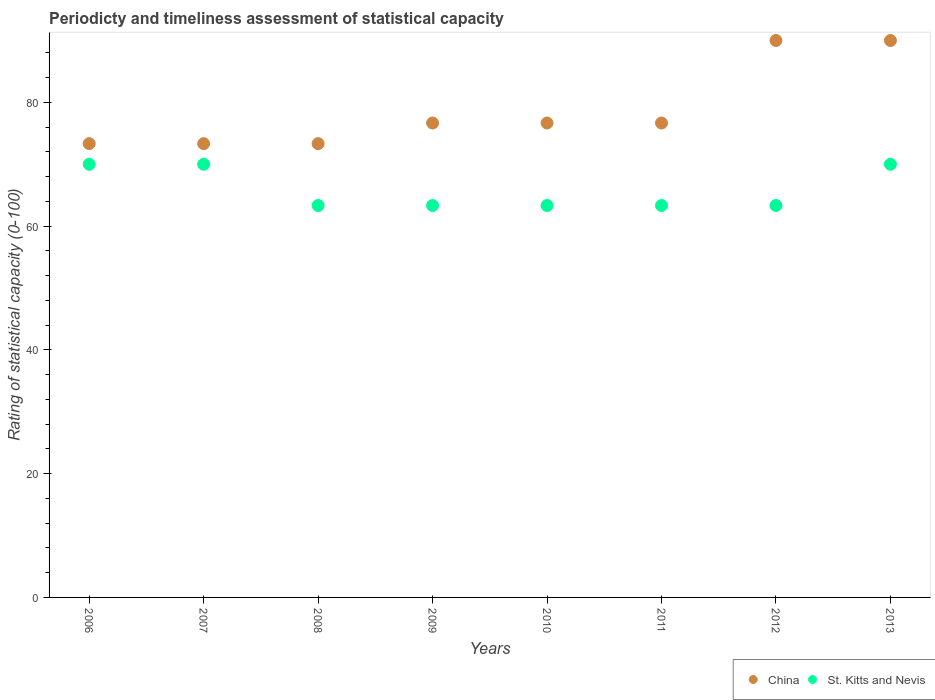How many different coloured dotlines are there?
Offer a very short reply. 2. Is the number of dotlines equal to the number of legend labels?
Your response must be concise. Yes. What is the rating of statistical capacity in China in 2011?
Your answer should be very brief. 76.67. Across all years, what is the minimum rating of statistical capacity in China?
Your answer should be compact. 73.33. In which year was the rating of statistical capacity in China maximum?
Your answer should be compact. 2012. What is the total rating of statistical capacity in China in the graph?
Your response must be concise. 630. What is the difference between the rating of statistical capacity in China in 2008 and that in 2013?
Your answer should be compact. -16.67. What is the difference between the rating of statistical capacity in China in 2013 and the rating of statistical capacity in St. Kitts and Nevis in 2009?
Offer a terse response. 26.67. What is the average rating of statistical capacity in St. Kitts and Nevis per year?
Give a very brief answer. 65.83. In the year 2006, what is the difference between the rating of statistical capacity in St. Kitts and Nevis and rating of statistical capacity in China?
Ensure brevity in your answer.  -3.33. In how many years, is the rating of statistical capacity in St. Kitts and Nevis greater than 4?
Your answer should be compact. 8. What is the ratio of the rating of statistical capacity in St. Kitts and Nevis in 2006 to that in 2008?
Your answer should be very brief. 1.11. Is the rating of statistical capacity in China in 2006 less than that in 2009?
Your answer should be compact. Yes. What is the difference between the highest and the lowest rating of statistical capacity in China?
Keep it short and to the point. 16.67. Is the sum of the rating of statistical capacity in St. Kitts and Nevis in 2008 and 2009 greater than the maximum rating of statistical capacity in China across all years?
Provide a succinct answer. Yes. Does the rating of statistical capacity in China monotonically increase over the years?
Your answer should be compact. No. Is the rating of statistical capacity in China strictly less than the rating of statistical capacity in St. Kitts and Nevis over the years?
Your answer should be compact. No. How many dotlines are there?
Give a very brief answer. 2. How many years are there in the graph?
Provide a short and direct response. 8. Are the values on the major ticks of Y-axis written in scientific E-notation?
Provide a short and direct response. No. How many legend labels are there?
Provide a succinct answer. 2. How are the legend labels stacked?
Provide a succinct answer. Horizontal. What is the title of the graph?
Offer a very short reply. Periodicty and timeliness assessment of statistical capacity. Does "Malawi" appear as one of the legend labels in the graph?
Offer a very short reply. No. What is the label or title of the X-axis?
Offer a very short reply. Years. What is the label or title of the Y-axis?
Offer a very short reply. Rating of statistical capacity (0-100). What is the Rating of statistical capacity (0-100) in China in 2006?
Your answer should be compact. 73.33. What is the Rating of statistical capacity (0-100) of St. Kitts and Nevis in 2006?
Ensure brevity in your answer.  70. What is the Rating of statistical capacity (0-100) of China in 2007?
Your answer should be very brief. 73.33. What is the Rating of statistical capacity (0-100) of St. Kitts and Nevis in 2007?
Your answer should be compact. 70. What is the Rating of statistical capacity (0-100) of China in 2008?
Offer a very short reply. 73.33. What is the Rating of statistical capacity (0-100) in St. Kitts and Nevis in 2008?
Offer a very short reply. 63.33. What is the Rating of statistical capacity (0-100) of China in 2009?
Ensure brevity in your answer.  76.67. What is the Rating of statistical capacity (0-100) of St. Kitts and Nevis in 2009?
Offer a terse response. 63.33. What is the Rating of statistical capacity (0-100) in China in 2010?
Offer a very short reply. 76.67. What is the Rating of statistical capacity (0-100) in St. Kitts and Nevis in 2010?
Provide a succinct answer. 63.33. What is the Rating of statistical capacity (0-100) in China in 2011?
Offer a terse response. 76.67. What is the Rating of statistical capacity (0-100) of St. Kitts and Nevis in 2011?
Ensure brevity in your answer.  63.33. What is the Rating of statistical capacity (0-100) in St. Kitts and Nevis in 2012?
Give a very brief answer. 63.33. Across all years, what is the maximum Rating of statistical capacity (0-100) of St. Kitts and Nevis?
Your answer should be very brief. 70. Across all years, what is the minimum Rating of statistical capacity (0-100) in China?
Provide a succinct answer. 73.33. Across all years, what is the minimum Rating of statistical capacity (0-100) of St. Kitts and Nevis?
Offer a very short reply. 63.33. What is the total Rating of statistical capacity (0-100) in China in the graph?
Your answer should be compact. 630. What is the total Rating of statistical capacity (0-100) in St. Kitts and Nevis in the graph?
Your answer should be compact. 526.67. What is the difference between the Rating of statistical capacity (0-100) in China in 2006 and that in 2007?
Make the answer very short. 0. What is the difference between the Rating of statistical capacity (0-100) of St. Kitts and Nevis in 2006 and that in 2008?
Your answer should be compact. 6.67. What is the difference between the Rating of statistical capacity (0-100) of China in 2006 and that in 2009?
Make the answer very short. -3.33. What is the difference between the Rating of statistical capacity (0-100) in St. Kitts and Nevis in 2006 and that in 2009?
Your answer should be compact. 6.67. What is the difference between the Rating of statistical capacity (0-100) of St. Kitts and Nevis in 2006 and that in 2010?
Give a very brief answer. 6.67. What is the difference between the Rating of statistical capacity (0-100) in St. Kitts and Nevis in 2006 and that in 2011?
Provide a succinct answer. 6.67. What is the difference between the Rating of statistical capacity (0-100) in China in 2006 and that in 2012?
Offer a terse response. -16.67. What is the difference between the Rating of statistical capacity (0-100) of St. Kitts and Nevis in 2006 and that in 2012?
Your answer should be very brief. 6.67. What is the difference between the Rating of statistical capacity (0-100) in China in 2006 and that in 2013?
Ensure brevity in your answer.  -16.67. What is the difference between the Rating of statistical capacity (0-100) in St. Kitts and Nevis in 2006 and that in 2013?
Your response must be concise. 0. What is the difference between the Rating of statistical capacity (0-100) of China in 2007 and that in 2012?
Provide a short and direct response. -16.67. What is the difference between the Rating of statistical capacity (0-100) of St. Kitts and Nevis in 2007 and that in 2012?
Give a very brief answer. 6.67. What is the difference between the Rating of statistical capacity (0-100) of China in 2007 and that in 2013?
Your response must be concise. -16.67. What is the difference between the Rating of statistical capacity (0-100) in China in 2008 and that in 2009?
Provide a succinct answer. -3.33. What is the difference between the Rating of statistical capacity (0-100) in St. Kitts and Nevis in 2008 and that in 2009?
Ensure brevity in your answer.  0. What is the difference between the Rating of statistical capacity (0-100) in St. Kitts and Nevis in 2008 and that in 2010?
Make the answer very short. 0. What is the difference between the Rating of statistical capacity (0-100) in St. Kitts and Nevis in 2008 and that in 2011?
Ensure brevity in your answer.  0. What is the difference between the Rating of statistical capacity (0-100) in China in 2008 and that in 2012?
Make the answer very short. -16.67. What is the difference between the Rating of statistical capacity (0-100) of St. Kitts and Nevis in 2008 and that in 2012?
Provide a short and direct response. 0. What is the difference between the Rating of statistical capacity (0-100) of China in 2008 and that in 2013?
Your answer should be very brief. -16.67. What is the difference between the Rating of statistical capacity (0-100) in St. Kitts and Nevis in 2008 and that in 2013?
Your response must be concise. -6.67. What is the difference between the Rating of statistical capacity (0-100) in China in 2009 and that in 2012?
Provide a succinct answer. -13.33. What is the difference between the Rating of statistical capacity (0-100) in St. Kitts and Nevis in 2009 and that in 2012?
Offer a very short reply. 0. What is the difference between the Rating of statistical capacity (0-100) of China in 2009 and that in 2013?
Your response must be concise. -13.33. What is the difference between the Rating of statistical capacity (0-100) in St. Kitts and Nevis in 2009 and that in 2013?
Keep it short and to the point. -6.67. What is the difference between the Rating of statistical capacity (0-100) of St. Kitts and Nevis in 2010 and that in 2011?
Give a very brief answer. 0. What is the difference between the Rating of statistical capacity (0-100) of China in 2010 and that in 2012?
Ensure brevity in your answer.  -13.33. What is the difference between the Rating of statistical capacity (0-100) of St. Kitts and Nevis in 2010 and that in 2012?
Provide a succinct answer. 0. What is the difference between the Rating of statistical capacity (0-100) in China in 2010 and that in 2013?
Offer a terse response. -13.33. What is the difference between the Rating of statistical capacity (0-100) of St. Kitts and Nevis in 2010 and that in 2013?
Your answer should be very brief. -6.67. What is the difference between the Rating of statistical capacity (0-100) in China in 2011 and that in 2012?
Give a very brief answer. -13.33. What is the difference between the Rating of statistical capacity (0-100) of China in 2011 and that in 2013?
Offer a very short reply. -13.33. What is the difference between the Rating of statistical capacity (0-100) of St. Kitts and Nevis in 2011 and that in 2013?
Make the answer very short. -6.67. What is the difference between the Rating of statistical capacity (0-100) of St. Kitts and Nevis in 2012 and that in 2013?
Your answer should be very brief. -6.67. What is the difference between the Rating of statistical capacity (0-100) of China in 2006 and the Rating of statistical capacity (0-100) of St. Kitts and Nevis in 2007?
Provide a short and direct response. 3.33. What is the difference between the Rating of statistical capacity (0-100) of China in 2006 and the Rating of statistical capacity (0-100) of St. Kitts and Nevis in 2009?
Offer a very short reply. 10. What is the difference between the Rating of statistical capacity (0-100) in China in 2006 and the Rating of statistical capacity (0-100) in St. Kitts and Nevis in 2010?
Offer a very short reply. 10. What is the difference between the Rating of statistical capacity (0-100) of China in 2006 and the Rating of statistical capacity (0-100) of St. Kitts and Nevis in 2012?
Keep it short and to the point. 10. What is the difference between the Rating of statistical capacity (0-100) of China in 2007 and the Rating of statistical capacity (0-100) of St. Kitts and Nevis in 2008?
Your response must be concise. 10. What is the difference between the Rating of statistical capacity (0-100) of China in 2007 and the Rating of statistical capacity (0-100) of St. Kitts and Nevis in 2009?
Make the answer very short. 10. What is the difference between the Rating of statistical capacity (0-100) of China in 2007 and the Rating of statistical capacity (0-100) of St. Kitts and Nevis in 2010?
Your answer should be very brief. 10. What is the difference between the Rating of statistical capacity (0-100) of China in 2007 and the Rating of statistical capacity (0-100) of St. Kitts and Nevis in 2012?
Offer a very short reply. 10. What is the difference between the Rating of statistical capacity (0-100) in China in 2008 and the Rating of statistical capacity (0-100) in St. Kitts and Nevis in 2012?
Your answer should be very brief. 10. What is the difference between the Rating of statistical capacity (0-100) of China in 2009 and the Rating of statistical capacity (0-100) of St. Kitts and Nevis in 2010?
Offer a terse response. 13.33. What is the difference between the Rating of statistical capacity (0-100) in China in 2009 and the Rating of statistical capacity (0-100) in St. Kitts and Nevis in 2011?
Provide a succinct answer. 13.33. What is the difference between the Rating of statistical capacity (0-100) in China in 2009 and the Rating of statistical capacity (0-100) in St. Kitts and Nevis in 2012?
Your response must be concise. 13.33. What is the difference between the Rating of statistical capacity (0-100) in China in 2009 and the Rating of statistical capacity (0-100) in St. Kitts and Nevis in 2013?
Ensure brevity in your answer.  6.67. What is the difference between the Rating of statistical capacity (0-100) in China in 2010 and the Rating of statistical capacity (0-100) in St. Kitts and Nevis in 2011?
Your answer should be very brief. 13.33. What is the difference between the Rating of statistical capacity (0-100) of China in 2010 and the Rating of statistical capacity (0-100) of St. Kitts and Nevis in 2012?
Provide a succinct answer. 13.33. What is the difference between the Rating of statistical capacity (0-100) of China in 2011 and the Rating of statistical capacity (0-100) of St. Kitts and Nevis in 2012?
Your answer should be very brief. 13.33. What is the difference between the Rating of statistical capacity (0-100) of China in 2011 and the Rating of statistical capacity (0-100) of St. Kitts and Nevis in 2013?
Provide a short and direct response. 6.67. What is the average Rating of statistical capacity (0-100) of China per year?
Provide a short and direct response. 78.75. What is the average Rating of statistical capacity (0-100) in St. Kitts and Nevis per year?
Make the answer very short. 65.83. In the year 2006, what is the difference between the Rating of statistical capacity (0-100) in China and Rating of statistical capacity (0-100) in St. Kitts and Nevis?
Offer a terse response. 3.33. In the year 2009, what is the difference between the Rating of statistical capacity (0-100) of China and Rating of statistical capacity (0-100) of St. Kitts and Nevis?
Your answer should be very brief. 13.33. In the year 2010, what is the difference between the Rating of statistical capacity (0-100) of China and Rating of statistical capacity (0-100) of St. Kitts and Nevis?
Provide a succinct answer. 13.33. In the year 2011, what is the difference between the Rating of statistical capacity (0-100) in China and Rating of statistical capacity (0-100) in St. Kitts and Nevis?
Your response must be concise. 13.33. In the year 2012, what is the difference between the Rating of statistical capacity (0-100) in China and Rating of statistical capacity (0-100) in St. Kitts and Nevis?
Your response must be concise. 26.67. In the year 2013, what is the difference between the Rating of statistical capacity (0-100) in China and Rating of statistical capacity (0-100) in St. Kitts and Nevis?
Provide a succinct answer. 20. What is the ratio of the Rating of statistical capacity (0-100) in St. Kitts and Nevis in 2006 to that in 2007?
Your answer should be compact. 1. What is the ratio of the Rating of statistical capacity (0-100) in St. Kitts and Nevis in 2006 to that in 2008?
Offer a very short reply. 1.11. What is the ratio of the Rating of statistical capacity (0-100) in China in 2006 to that in 2009?
Offer a terse response. 0.96. What is the ratio of the Rating of statistical capacity (0-100) in St. Kitts and Nevis in 2006 to that in 2009?
Provide a short and direct response. 1.11. What is the ratio of the Rating of statistical capacity (0-100) in China in 2006 to that in 2010?
Your answer should be very brief. 0.96. What is the ratio of the Rating of statistical capacity (0-100) of St. Kitts and Nevis in 2006 to that in 2010?
Your response must be concise. 1.11. What is the ratio of the Rating of statistical capacity (0-100) of China in 2006 to that in 2011?
Give a very brief answer. 0.96. What is the ratio of the Rating of statistical capacity (0-100) of St. Kitts and Nevis in 2006 to that in 2011?
Make the answer very short. 1.11. What is the ratio of the Rating of statistical capacity (0-100) of China in 2006 to that in 2012?
Offer a terse response. 0.81. What is the ratio of the Rating of statistical capacity (0-100) in St. Kitts and Nevis in 2006 to that in 2012?
Keep it short and to the point. 1.11. What is the ratio of the Rating of statistical capacity (0-100) of China in 2006 to that in 2013?
Provide a succinct answer. 0.81. What is the ratio of the Rating of statistical capacity (0-100) of St. Kitts and Nevis in 2006 to that in 2013?
Your answer should be very brief. 1. What is the ratio of the Rating of statistical capacity (0-100) of China in 2007 to that in 2008?
Provide a succinct answer. 1. What is the ratio of the Rating of statistical capacity (0-100) in St. Kitts and Nevis in 2007 to that in 2008?
Offer a terse response. 1.11. What is the ratio of the Rating of statistical capacity (0-100) of China in 2007 to that in 2009?
Provide a short and direct response. 0.96. What is the ratio of the Rating of statistical capacity (0-100) in St. Kitts and Nevis in 2007 to that in 2009?
Make the answer very short. 1.11. What is the ratio of the Rating of statistical capacity (0-100) in China in 2007 to that in 2010?
Your response must be concise. 0.96. What is the ratio of the Rating of statistical capacity (0-100) in St. Kitts and Nevis in 2007 to that in 2010?
Your response must be concise. 1.11. What is the ratio of the Rating of statistical capacity (0-100) in China in 2007 to that in 2011?
Keep it short and to the point. 0.96. What is the ratio of the Rating of statistical capacity (0-100) in St. Kitts and Nevis in 2007 to that in 2011?
Offer a terse response. 1.11. What is the ratio of the Rating of statistical capacity (0-100) of China in 2007 to that in 2012?
Your answer should be very brief. 0.81. What is the ratio of the Rating of statistical capacity (0-100) in St. Kitts and Nevis in 2007 to that in 2012?
Your answer should be very brief. 1.11. What is the ratio of the Rating of statistical capacity (0-100) of China in 2007 to that in 2013?
Provide a short and direct response. 0.81. What is the ratio of the Rating of statistical capacity (0-100) in China in 2008 to that in 2009?
Provide a short and direct response. 0.96. What is the ratio of the Rating of statistical capacity (0-100) in St. Kitts and Nevis in 2008 to that in 2009?
Your answer should be very brief. 1. What is the ratio of the Rating of statistical capacity (0-100) of China in 2008 to that in 2010?
Provide a succinct answer. 0.96. What is the ratio of the Rating of statistical capacity (0-100) in China in 2008 to that in 2011?
Your answer should be very brief. 0.96. What is the ratio of the Rating of statistical capacity (0-100) of China in 2008 to that in 2012?
Your answer should be very brief. 0.81. What is the ratio of the Rating of statistical capacity (0-100) of St. Kitts and Nevis in 2008 to that in 2012?
Offer a very short reply. 1. What is the ratio of the Rating of statistical capacity (0-100) in China in 2008 to that in 2013?
Ensure brevity in your answer.  0.81. What is the ratio of the Rating of statistical capacity (0-100) of St. Kitts and Nevis in 2008 to that in 2013?
Your answer should be very brief. 0.9. What is the ratio of the Rating of statistical capacity (0-100) in China in 2009 to that in 2010?
Make the answer very short. 1. What is the ratio of the Rating of statistical capacity (0-100) in China in 2009 to that in 2011?
Make the answer very short. 1. What is the ratio of the Rating of statistical capacity (0-100) in St. Kitts and Nevis in 2009 to that in 2011?
Your answer should be very brief. 1. What is the ratio of the Rating of statistical capacity (0-100) in China in 2009 to that in 2012?
Your response must be concise. 0.85. What is the ratio of the Rating of statistical capacity (0-100) of China in 2009 to that in 2013?
Provide a succinct answer. 0.85. What is the ratio of the Rating of statistical capacity (0-100) of St. Kitts and Nevis in 2009 to that in 2013?
Give a very brief answer. 0.9. What is the ratio of the Rating of statistical capacity (0-100) of China in 2010 to that in 2011?
Your response must be concise. 1. What is the ratio of the Rating of statistical capacity (0-100) of China in 2010 to that in 2012?
Give a very brief answer. 0.85. What is the ratio of the Rating of statistical capacity (0-100) of St. Kitts and Nevis in 2010 to that in 2012?
Your answer should be very brief. 1. What is the ratio of the Rating of statistical capacity (0-100) in China in 2010 to that in 2013?
Keep it short and to the point. 0.85. What is the ratio of the Rating of statistical capacity (0-100) of St. Kitts and Nevis in 2010 to that in 2013?
Provide a succinct answer. 0.9. What is the ratio of the Rating of statistical capacity (0-100) in China in 2011 to that in 2012?
Keep it short and to the point. 0.85. What is the ratio of the Rating of statistical capacity (0-100) in St. Kitts and Nevis in 2011 to that in 2012?
Your response must be concise. 1. What is the ratio of the Rating of statistical capacity (0-100) in China in 2011 to that in 2013?
Provide a short and direct response. 0.85. What is the ratio of the Rating of statistical capacity (0-100) of St. Kitts and Nevis in 2011 to that in 2013?
Give a very brief answer. 0.9. What is the ratio of the Rating of statistical capacity (0-100) in St. Kitts and Nevis in 2012 to that in 2013?
Offer a very short reply. 0.9. What is the difference between the highest and the second highest Rating of statistical capacity (0-100) of China?
Ensure brevity in your answer.  0. What is the difference between the highest and the lowest Rating of statistical capacity (0-100) of China?
Provide a short and direct response. 16.67. What is the difference between the highest and the lowest Rating of statistical capacity (0-100) in St. Kitts and Nevis?
Ensure brevity in your answer.  6.67. 